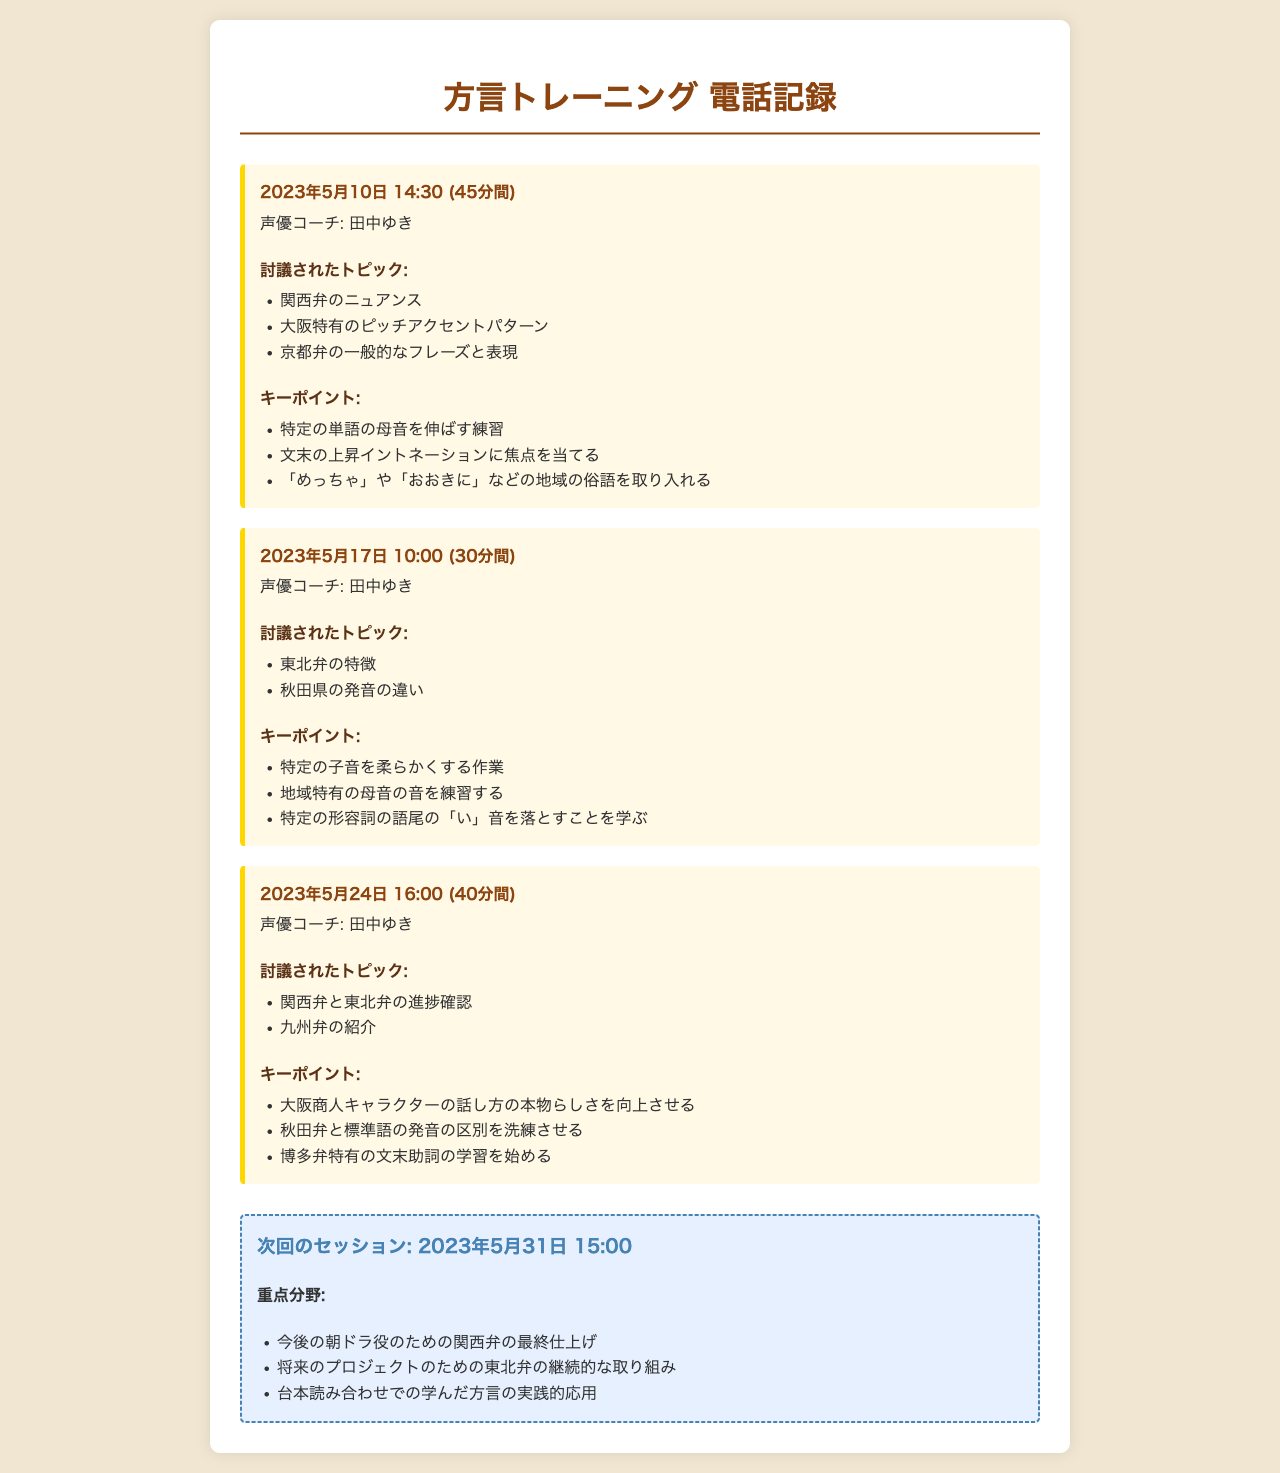What is the date of the first phone consultation? The first phone consultation is dated May 10, 2023.
Answer: 2023年5月10日 Who was the voice coach for the consultations? The voice coach mentioned in the document is 田中ゆき.
Answer: 田中ゆき How long was the second phone consultation? The duration of the second phone consultation was 30 minutes.
Answer: 30分間 What dialect was predominantly practiced in the third consultation? The predominant dialect practiced in the third consultation was 九州弁.
Answer: 九州弁 What are the key points discussed in the first consultation? Key points include practicing elongating specific vowel sounds and focusing on the rising intonation at the end of sentences.
Answer: 特定の単語の母音を伸ばす練習 When is the next session scheduled? The next session is scheduled for May 31, 2023.
Answer: 2023年5月31日 What topic was introduced during the third consultation? The topic introduced during the third consultation was 九州弁.
Answer: 九州弁 What is a specific phrase to incorporate from the first coaching session? A specific phrase to incorporate is 「おおきに」.
Answer: おおきに 